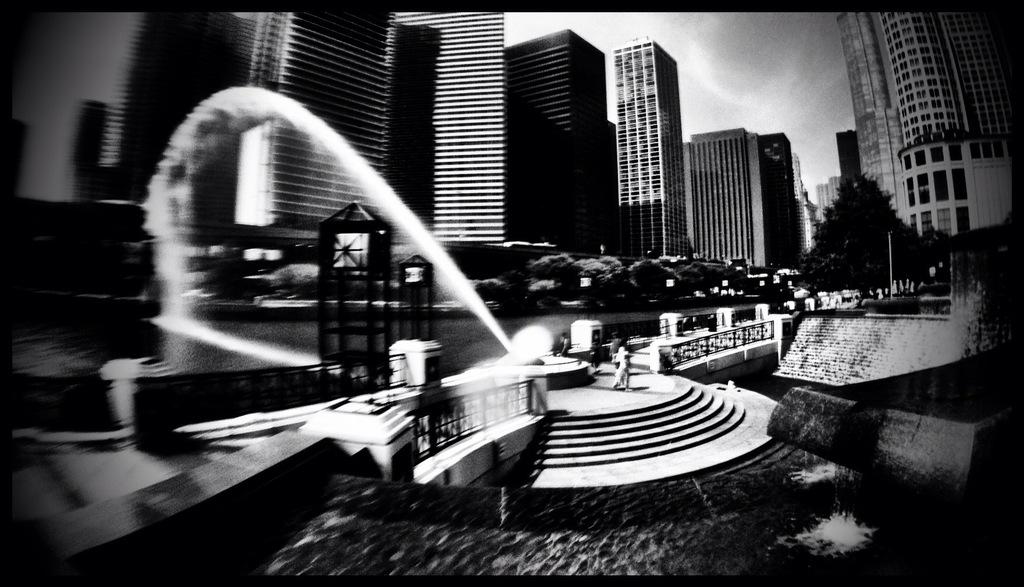What type of natural elements can be seen in the image? There are trees in the image. What type of man-made structures can be seen in the image? There are buildings, a fountain, a staircase, and a bridge in the image. What is the primary source of water in the image? There is a fountain in the image, which is a source of water. Can you describe the people in the image? There are people in the image, but their specific activities or characteristics are not mentioned in the provided facts. What is visible in the sky in the image? The sky is visible in the image, and there are clouds present. What color is the rose that the goose is holding in the image? There is no rose or goose present in the image. What activity are the people participating in, as seen in the image? The provided facts do not mention any specific activities that the people in the image are participating in. 